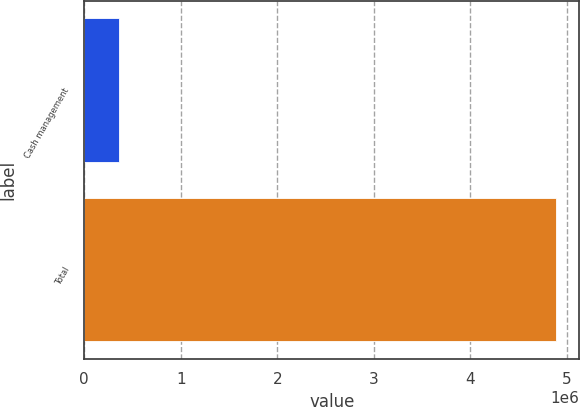Convert chart. <chart><loc_0><loc_0><loc_500><loc_500><bar_chart><fcel>Cash management<fcel>Total<nl><fcel>358498<fcel>4.88509e+06<nl></chart> 